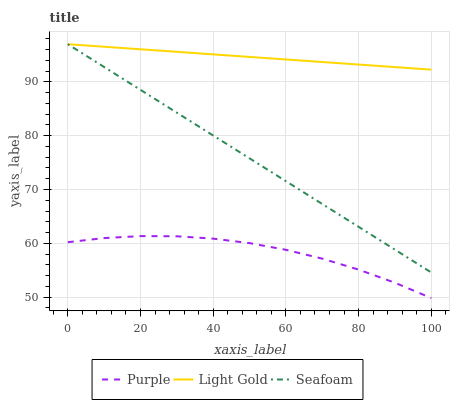Does Purple have the minimum area under the curve?
Answer yes or no. Yes. Does Light Gold have the maximum area under the curve?
Answer yes or no. Yes. Does Seafoam have the minimum area under the curve?
Answer yes or no. No. Does Seafoam have the maximum area under the curve?
Answer yes or no. No. Is Light Gold the smoothest?
Answer yes or no. Yes. Is Purple the roughest?
Answer yes or no. Yes. Is Seafoam the smoothest?
Answer yes or no. No. Is Seafoam the roughest?
Answer yes or no. No. Does Purple have the lowest value?
Answer yes or no. Yes. Does Seafoam have the lowest value?
Answer yes or no. No. Does Seafoam have the highest value?
Answer yes or no. Yes. Is Purple less than Light Gold?
Answer yes or no. Yes. Is Light Gold greater than Purple?
Answer yes or no. Yes. Does Light Gold intersect Seafoam?
Answer yes or no. Yes. Is Light Gold less than Seafoam?
Answer yes or no. No. Is Light Gold greater than Seafoam?
Answer yes or no. No. Does Purple intersect Light Gold?
Answer yes or no. No. 